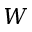<formula> <loc_0><loc_0><loc_500><loc_500>W</formula> 